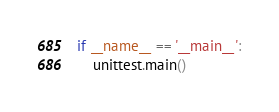<code> <loc_0><loc_0><loc_500><loc_500><_Python_>
if __name__ == '__main__':
    unittest.main()
</code> 